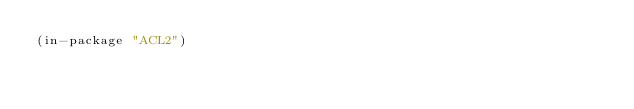Convert code to text. <code><loc_0><loc_0><loc_500><loc_500><_Lisp_>(in-package "ACL2")
</code> 